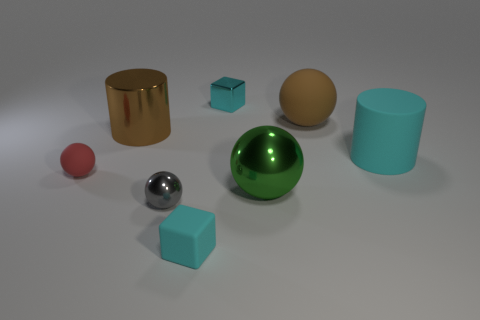What material is the gray sphere?
Provide a short and direct response. Metal. There is a tiny cyan thing in front of the large cyan matte cylinder; what is its material?
Offer a very short reply. Rubber. Is there anything else that is the same material as the large green ball?
Give a very brief answer. Yes. Are there more objects in front of the cyan metal cube than green things?
Make the answer very short. Yes. There is a matte thing behind the large metallic object behind the large green shiny thing; is there a cyan matte cylinder that is behind it?
Your response must be concise. No. There is a gray shiny sphere; are there any balls in front of it?
Your answer should be very brief. No. What number of cylinders are the same color as the metal cube?
Your response must be concise. 1. There is a cyan object that is made of the same material as the tiny gray ball; what is its size?
Your answer should be very brief. Small. What size is the cube that is to the left of the cyan cube that is behind the cylinder to the right of the brown metal cylinder?
Provide a succinct answer. Small. How big is the metal sphere behind the tiny gray shiny sphere?
Provide a succinct answer. Large. 